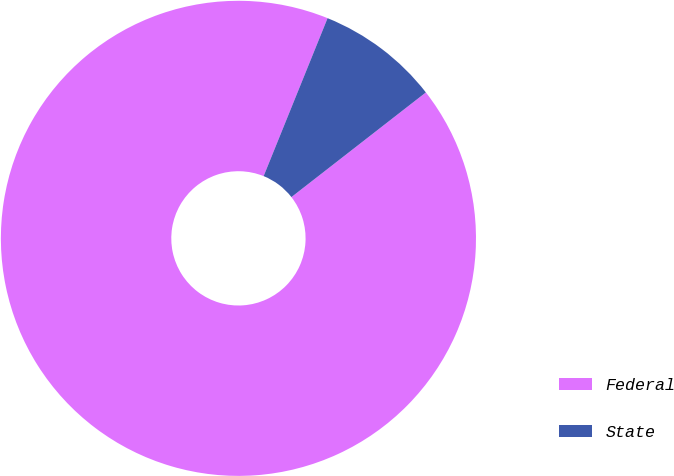Convert chart. <chart><loc_0><loc_0><loc_500><loc_500><pie_chart><fcel>Federal<fcel>State<nl><fcel>91.65%<fcel>8.35%<nl></chart> 